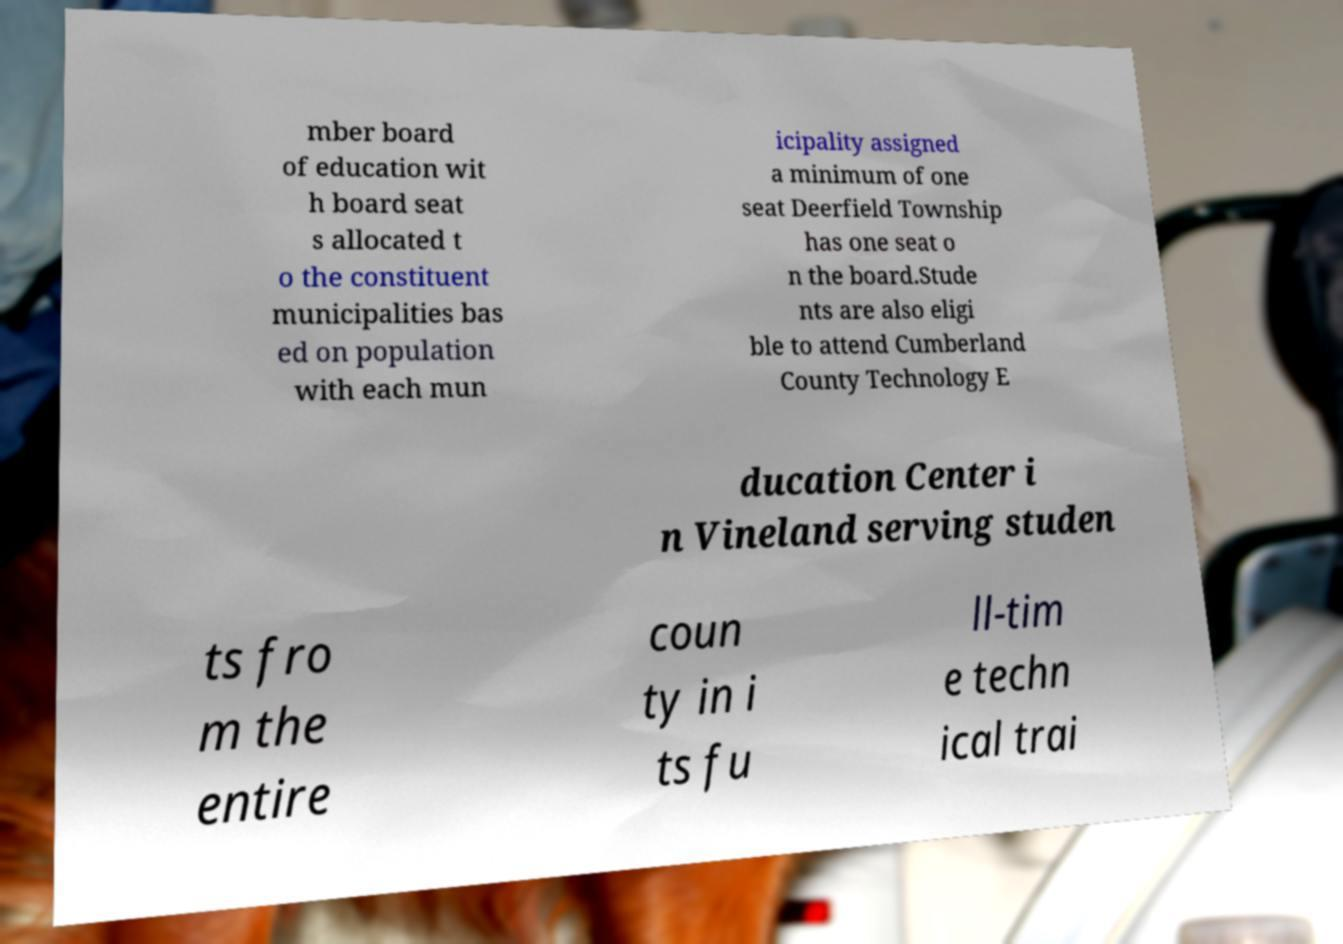What messages or text are displayed in this image? I need them in a readable, typed format. mber board of education wit h board seat s allocated t o the constituent municipalities bas ed on population with each mun icipality assigned a minimum of one seat Deerfield Township has one seat o n the board.Stude nts are also eligi ble to attend Cumberland County Technology E ducation Center i n Vineland serving studen ts fro m the entire coun ty in i ts fu ll-tim e techn ical trai 